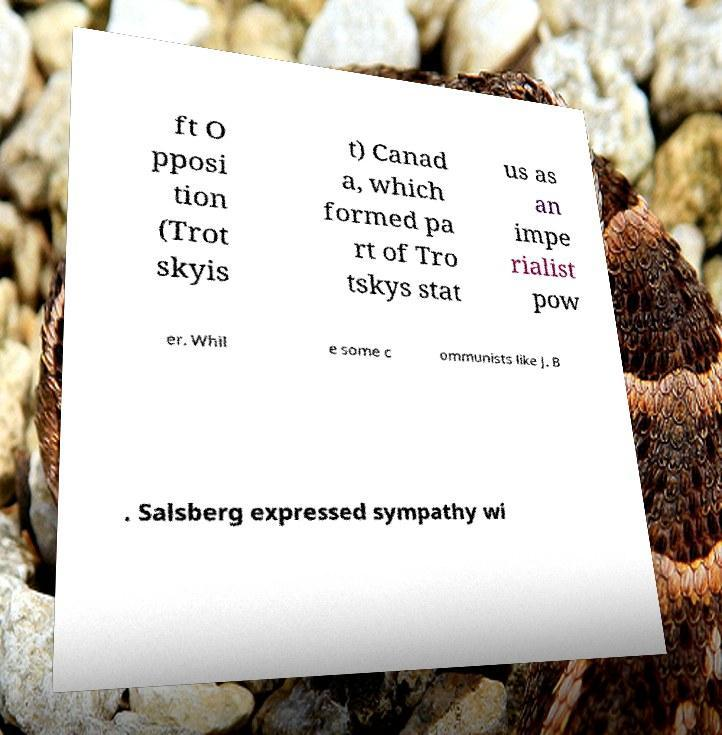Could you assist in decoding the text presented in this image and type it out clearly? ft O pposi tion (Trot skyis t) Canad a, which formed pa rt of Tro tskys stat us as an impe rialist pow er. Whil e some c ommunists like J. B . Salsberg expressed sympathy wi 